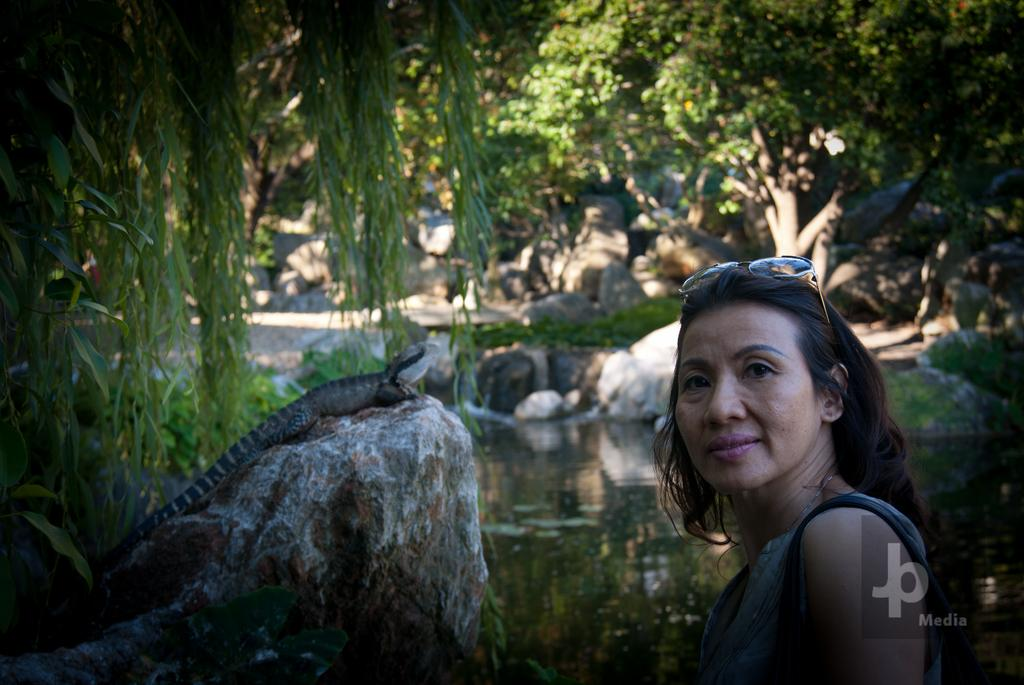Who is present in the image? There is a woman in the image. What is visible in the background of the image? Water, rocks, trees, and a reptile are visible in the image. What object is the woman wearing in the image? There are spectacles in the image. How many ants can be seen jumping in the image? There are no ants visible in the image, and they are not shown jumping. 